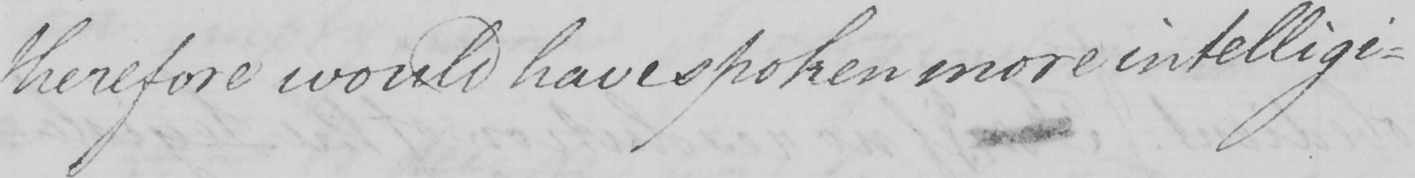What is written in this line of handwriting? therefore would have spoken more intelligi- 